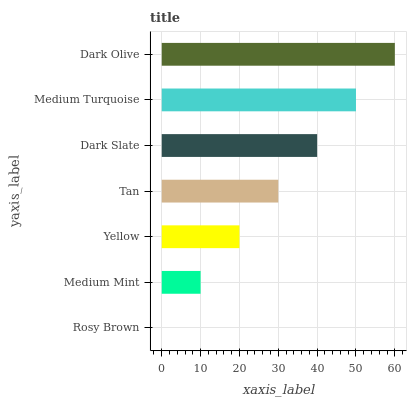Is Rosy Brown the minimum?
Answer yes or no. Yes. Is Dark Olive the maximum?
Answer yes or no. Yes. Is Medium Mint the minimum?
Answer yes or no. No. Is Medium Mint the maximum?
Answer yes or no. No. Is Medium Mint greater than Rosy Brown?
Answer yes or no. Yes. Is Rosy Brown less than Medium Mint?
Answer yes or no. Yes. Is Rosy Brown greater than Medium Mint?
Answer yes or no. No. Is Medium Mint less than Rosy Brown?
Answer yes or no. No. Is Tan the high median?
Answer yes or no. Yes. Is Tan the low median?
Answer yes or no. Yes. Is Yellow the high median?
Answer yes or no. No. Is Dark Olive the low median?
Answer yes or no. No. 